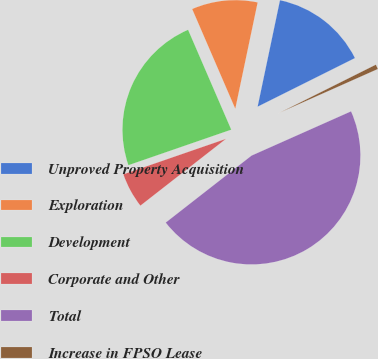<chart> <loc_0><loc_0><loc_500><loc_500><pie_chart><fcel>Unproved Property Acquisition<fcel>Exploration<fcel>Development<fcel>Corporate and Other<fcel>Total<fcel>Increase in FPSO Lease<nl><fcel>14.33%<fcel>9.79%<fcel>23.8%<fcel>5.25%<fcel>46.11%<fcel>0.71%<nl></chart> 